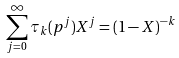Convert formula to latex. <formula><loc_0><loc_0><loc_500><loc_500>\sum _ { j = 0 } ^ { \infty } \tau _ { k } ( p ^ { j } ) X ^ { j } = ( 1 - X ) ^ { - k }</formula> 